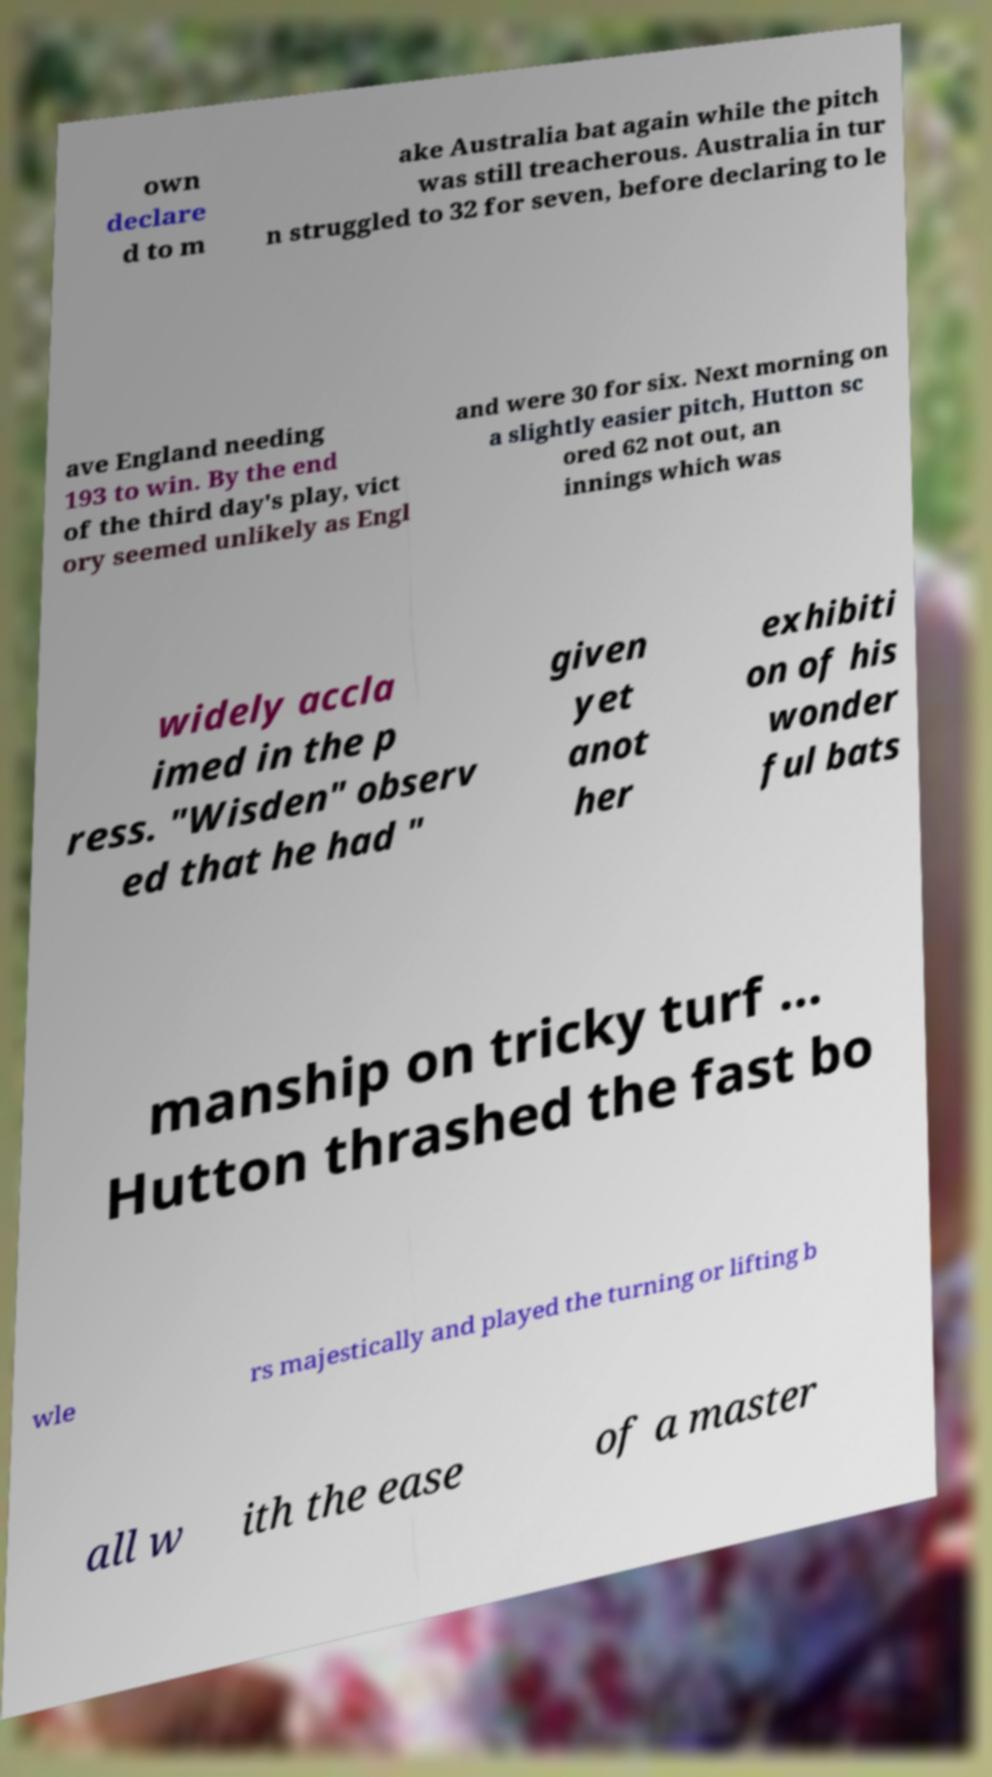Please identify and transcribe the text found in this image. own declare d to m ake Australia bat again while the pitch was still treacherous. Australia in tur n struggled to 32 for seven, before declaring to le ave England needing 193 to win. By the end of the third day's play, vict ory seemed unlikely as Engl and were 30 for six. Next morning on a slightly easier pitch, Hutton sc ored 62 not out, an innings which was widely accla imed in the p ress. "Wisden" observ ed that he had " given yet anot her exhibiti on of his wonder ful bats manship on tricky turf ... Hutton thrashed the fast bo wle rs majestically and played the turning or lifting b all w ith the ease of a master 